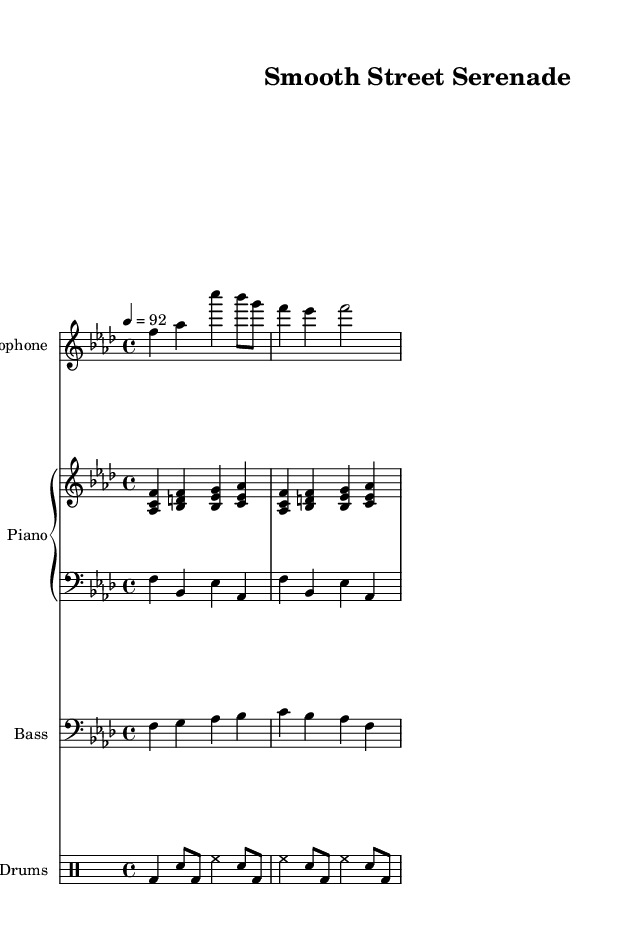What is the key signature of this music? The key signature is F minor, which has four flats (B, E, A, D). This can be identified at the beginning of the sheet music, indicating that F is the tonic note that gives the piece its tonal center.
Answer: F minor What is the time signature of this piece? The time signature is 4/4, shown at the beginning of the music. This indicates that there are four beats in each measure and a quarter note receives one beat, commonly known as "common time".
Answer: 4/4 What is the tempo marking of this score? The tempo marking is quarter note equals 92 beats per minute, indicated using the tempo marking at the beginning. This gives performers an idea of the speed at which the piece should be played.
Answer: 92 How many measures does the saxophone melody consist of? The saxophone melody contains three measures, which can be counted visually in the music staff by identifying the divisions created by the vertical lines. Each section between the lines represents a measure.
Answer: 3 What instruments are featured in this composition? The composition features saxophone, piano, bass, and drums, which are explicitly indicated by the different staves at the beginning of the score, each labeled with the respective instrument's name.
Answer: Saxophone, piano, bass, drums What type of chord is played by the right hand of the piano? The right hand of the piano primarily plays triadic chords, specifically instances of major chords like A flat major and B flat major, constructed using the notes that are stacked in thirds. This can be identified by analyzing the notes played by the right hand in the upper staff of the piano.
Answer: Triadic chords How does the bass line contribute to the hip hop feel? The bass line provides a rhythmic foundation characteristic of hip hop music, with its repetitive pattern that aligns with the kick drum setup, establishing a groove that supports the overall rhythmic feel of the piece, pivotal to hip hop's rhythmic structure.
Answer: Rhythmic foundation 